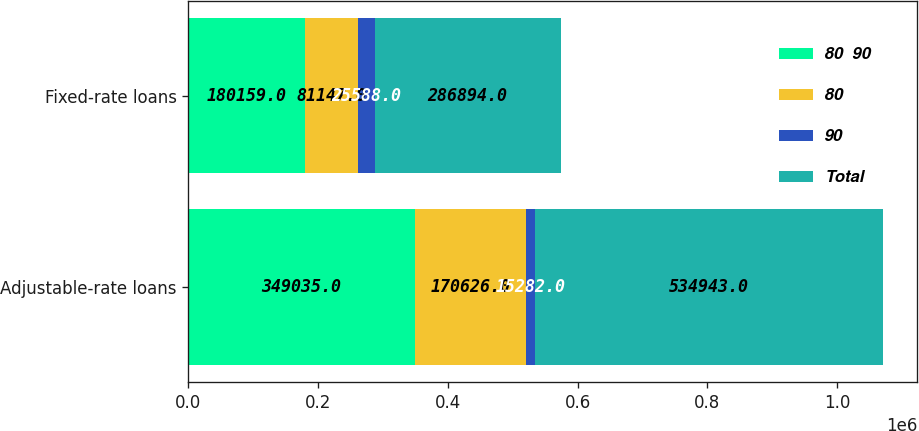Convert chart to OTSL. <chart><loc_0><loc_0><loc_500><loc_500><stacked_bar_chart><ecel><fcel>Adjustable-rate loans<fcel>Fixed-rate loans<nl><fcel>80  90<fcel>349035<fcel>180159<nl><fcel>80<fcel>170626<fcel>81147<nl><fcel>90<fcel>15282<fcel>25588<nl><fcel>Total<fcel>534943<fcel>286894<nl></chart> 